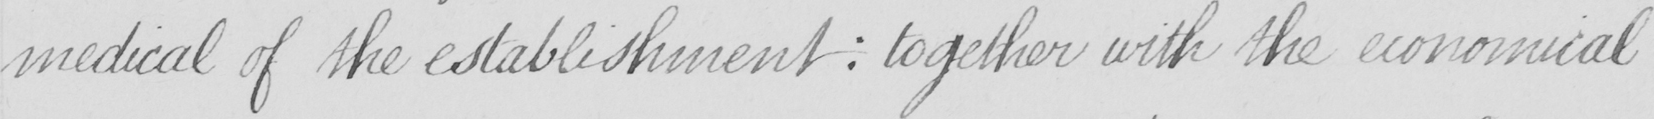Transcribe the text shown in this historical manuscript line. medical of the establishment  :  together with the economical 